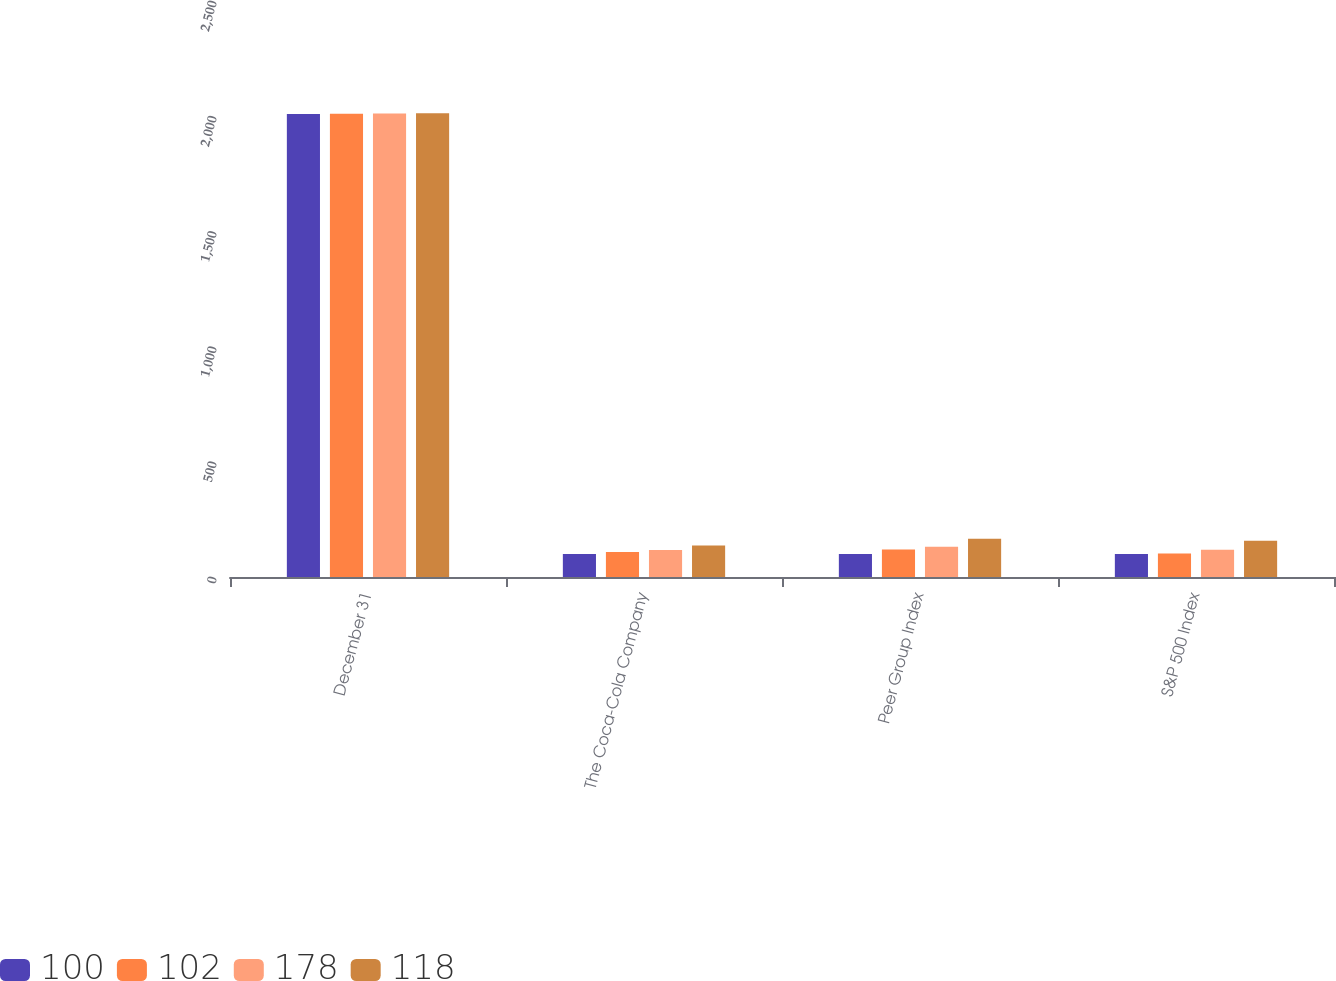Convert chart to OTSL. <chart><loc_0><loc_0><loc_500><loc_500><stacked_bar_chart><ecel><fcel>December 31<fcel>The Coca-Cola Company<fcel>Peer Group Index<fcel>S&P 500 Index<nl><fcel>100<fcel>2010<fcel>100<fcel>100<fcel>100<nl><fcel>102<fcel>2011<fcel>109<fcel>119<fcel>102<nl><fcel>178<fcel>2012<fcel>117<fcel>131<fcel>118<nl><fcel>118<fcel>2013<fcel>137<fcel>166<fcel>157<nl></chart> 